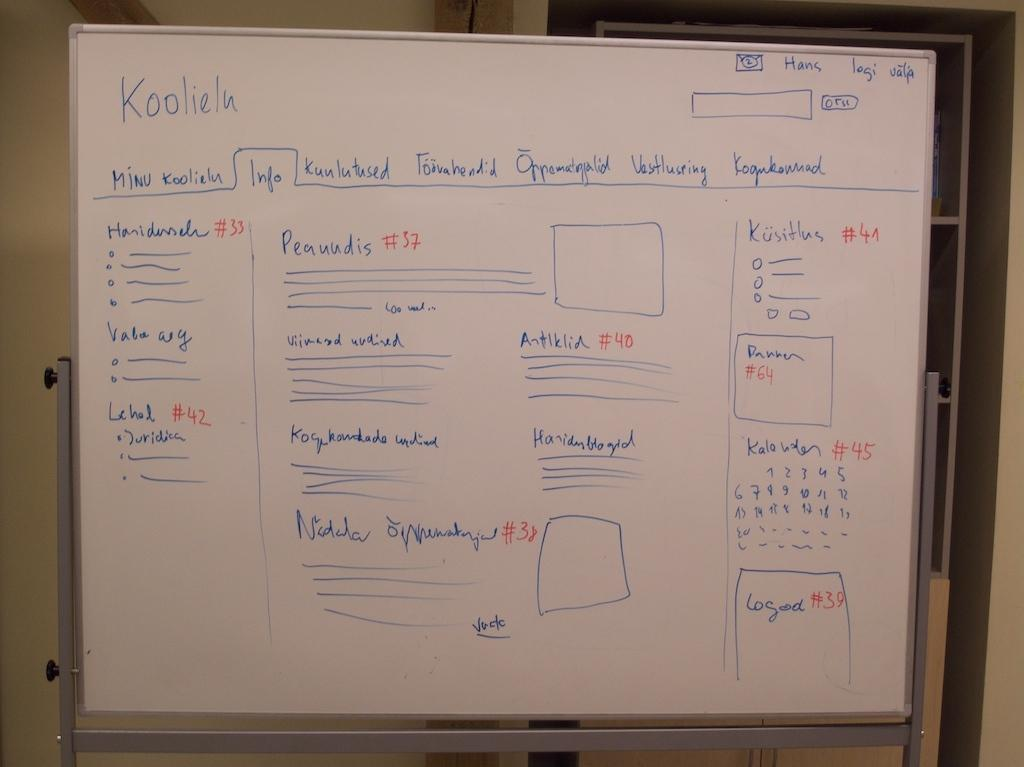Provide a one-sentence caption for the provided image. A whiteboard covered in words and diagrams written in blue marker, the word Koolieln is written in the top left. 